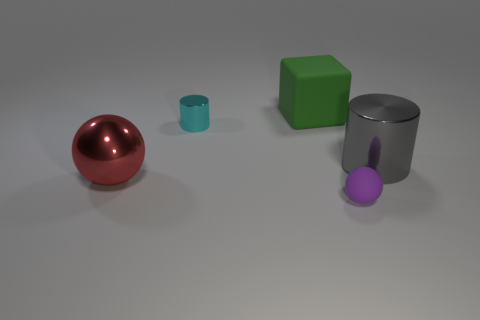Add 1 big blocks. How many objects exist? 6 Subtract all cubes. How many objects are left? 4 Subtract 0 green cylinders. How many objects are left? 5 Subtract all purple matte objects. Subtract all tiny gray metal things. How many objects are left? 4 Add 5 large green matte cubes. How many large green matte cubes are left? 6 Add 4 big cyan shiny cubes. How many big cyan shiny cubes exist? 4 